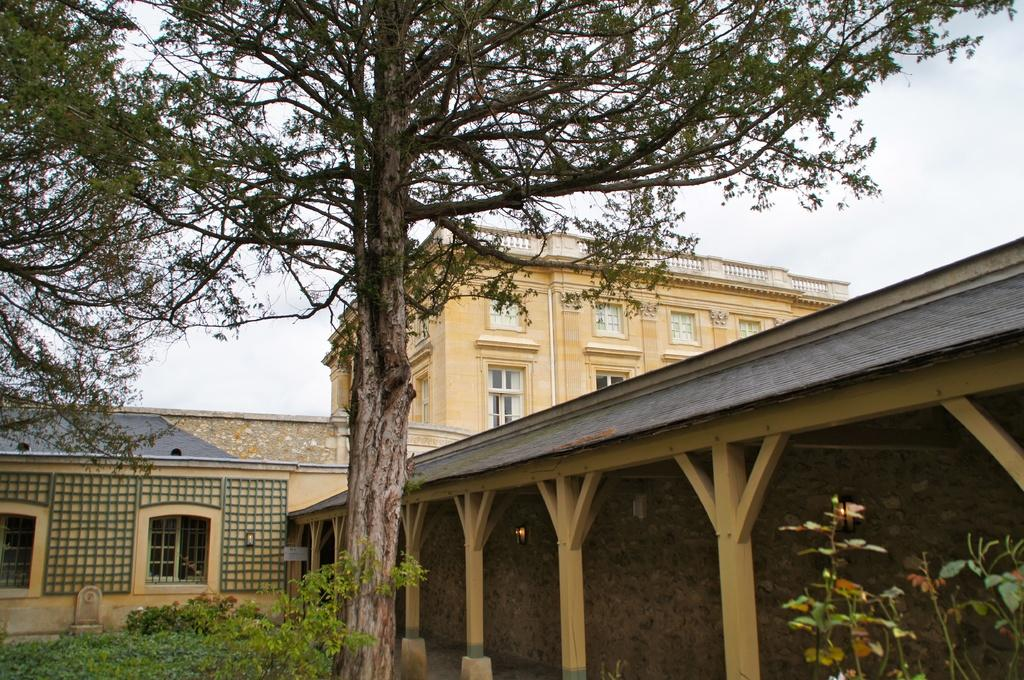What type of vegetation can be seen in the image? There are plants and trees in the image. What structures are present on the ground in the image? There is a shed and a house in the image. What other type of building can be seen in the image? There is a building in the image. What is visible in the background of the image? The sky is visible in the background of the image. Can you tell me how many kitties are playing with the machine in the image? There are no kitties or machines present in the image. What type of spring is visible in the image? There is no spring present in the image. 